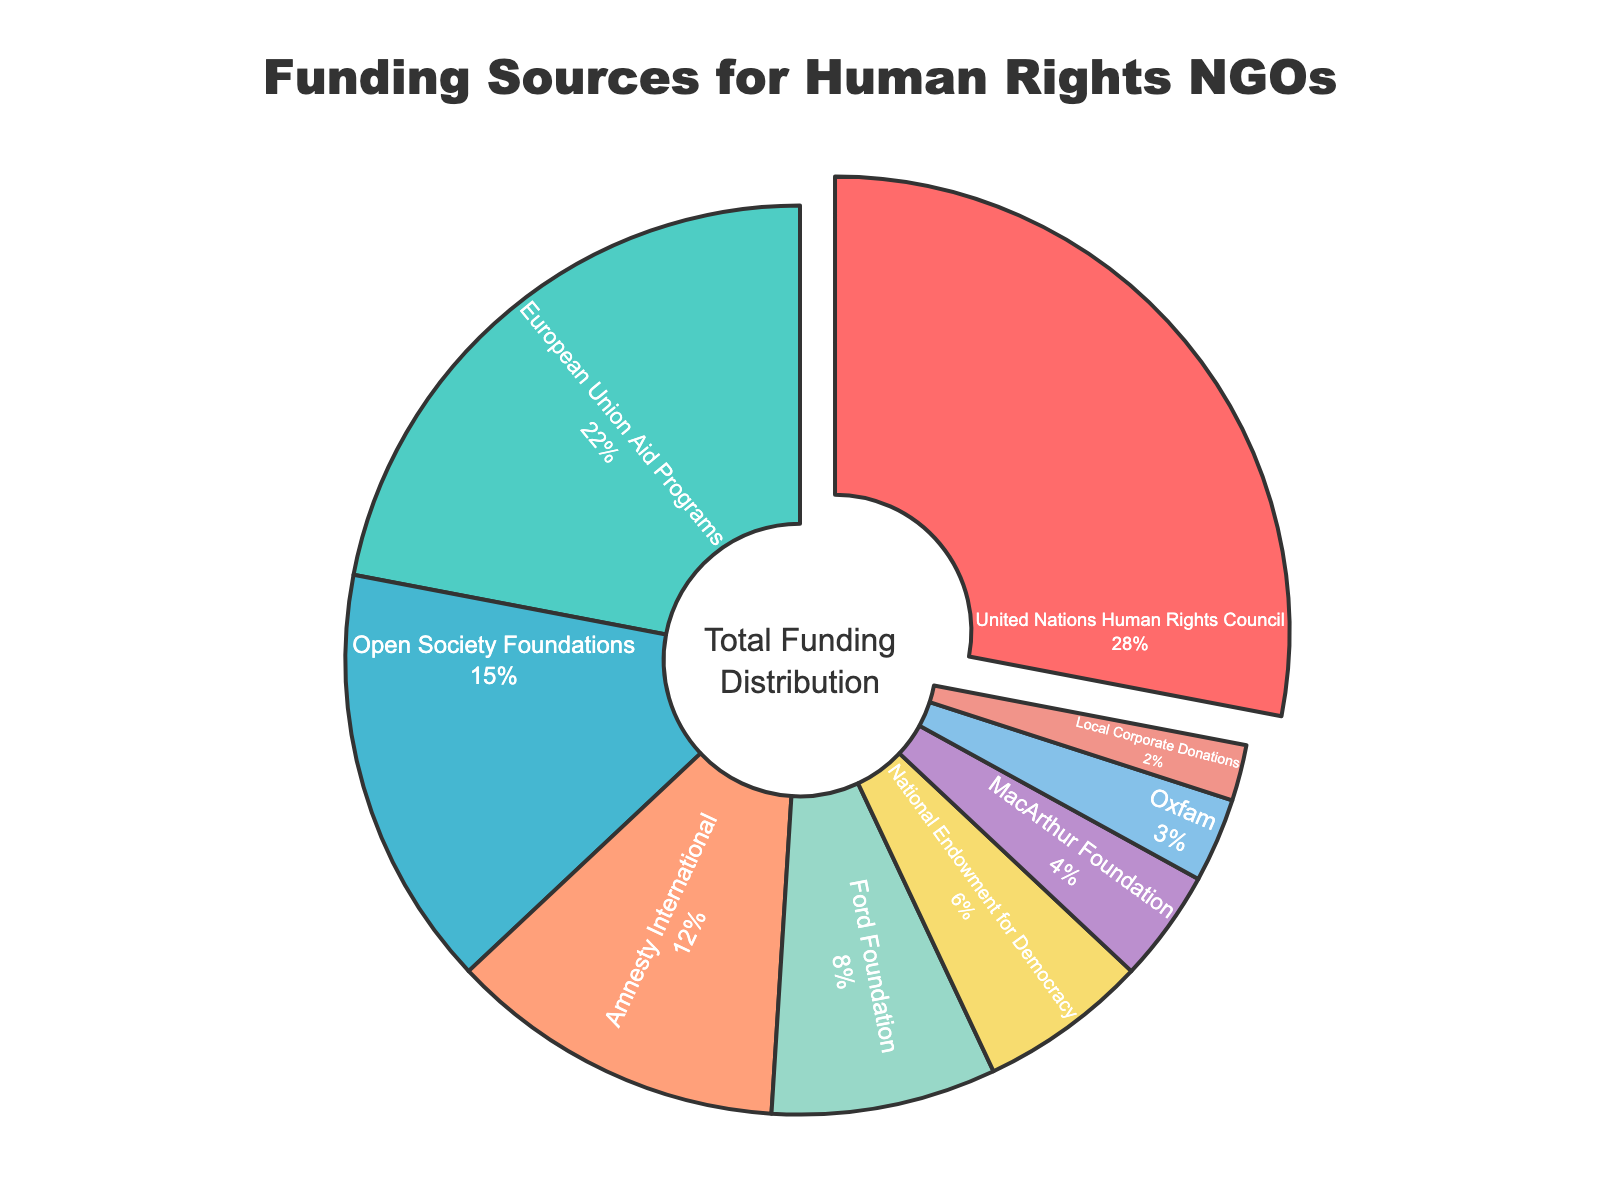What is the largest funding source for human rights NGOs? The largest funding source is represented by the largest portion of the pie chart. The section pulled out indicates the United Nations Human Rights Council is the largest with 28%.
Answer: United Nations Human Rights Council Which funding source contributes the least? The smallest section of the pie chart indicates the funding source that contributes the least, which is Local Corporate Donations with 2%.
Answer: Local Corporate Donations How much more funding comes from the United Nations Human Rights Council compared to the Ford Foundation? Identify the percentages for both the United Nations Human Rights Council (28%) and Ford Foundation (8%), and subtract the smaller percentage from the larger one: 28% - 8% = 20%.
Answer: 20% What is the combined percentage of funding from Open Society Foundations and Amnesty International? Add the percentages for Open Society Foundations (15%) and Amnesty International (12%): 15% + 12% = 27%.
Answer: 27% Is the percentage of funding from the European Union Aid Programs greater than the combined funding from Oxfam and the MacArthur Foundation? Compare the percentage from the European Union Aid Programs (22%) with the sum of Oxfam (3%) and MacArthur Foundation (4%): 3% + 4% = 7%. Since 22% > 7%, funding from the European Union Aid Programs is greater.
Answer: Yes What color represents the Ford Foundation funding source? Observe the color associated with the Ford Foundation section of the pie chart, which is light green.
Answer: Light green By what percentage do the top three funding sources (United Nations Human Rights Council, European Union Aid Programs, Open Society Foundations) exceed half of the total funding? Calculate the combined percentage of the top three sources: 28% + 22% + 15% = 65%. Then, determine how much this exceeds half of 100%, which is 50%: 65% - 50% = 15%.
Answer: 15% What is the difference in percentage points between the second smallest and the third smallest funding sources? Identify the second smallest (Local Corporate Donations, 2%) and the third smallest (Oxfam, 3%) sources and find the difference: 3% - 2% = 1%.
Answer: 1% Which funding source is represented by a dark blue section in the chart? Observe the color associated with each section and identify the one that is dark blue, which is the European Union Aid Programs.
Answer: European Union Aid Programs 